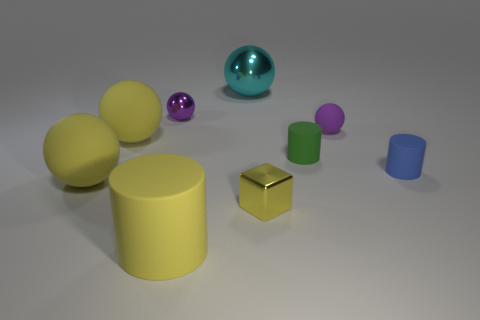Is there a big thing that is left of the yellow ball that is behind the blue cylinder?
Give a very brief answer. Yes. How many things are either big matte objects or cyan balls?
Make the answer very short. 4. The matte thing that is right of the big cylinder and to the left of the small rubber ball has what shape?
Your answer should be compact. Cylinder. Does the small purple thing to the left of the yellow metallic thing have the same material as the cyan object?
Offer a very short reply. Yes. How many things are large green shiny balls or purple objects that are in front of the tiny purple metal object?
Keep it short and to the point. 1. There is another big cylinder that is made of the same material as the green cylinder; what color is it?
Keep it short and to the point. Yellow. How many yellow cubes have the same material as the tiny green cylinder?
Provide a succinct answer. 0. What number of tiny shiny objects are there?
Keep it short and to the point. 2. There is a ball that is to the right of the green matte object; is it the same color as the small metallic thing that is behind the small yellow metallic block?
Provide a short and direct response. Yes. There is a small blue cylinder; how many spheres are in front of it?
Make the answer very short. 1. 